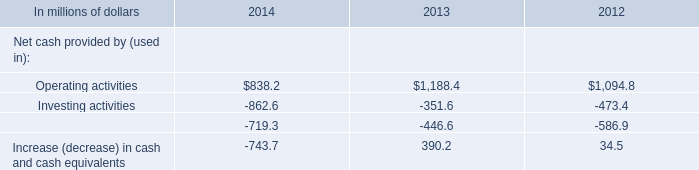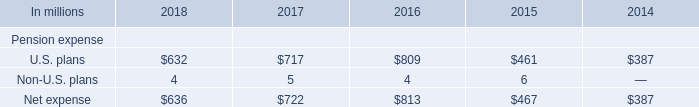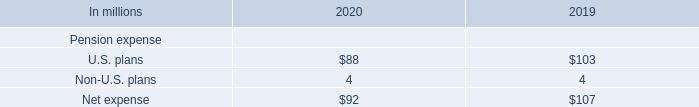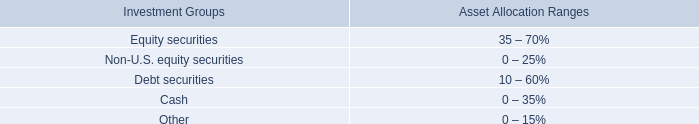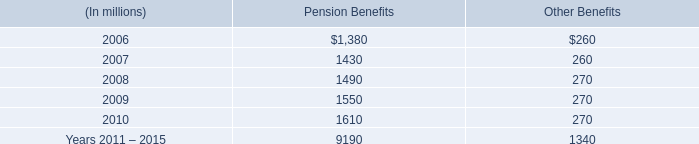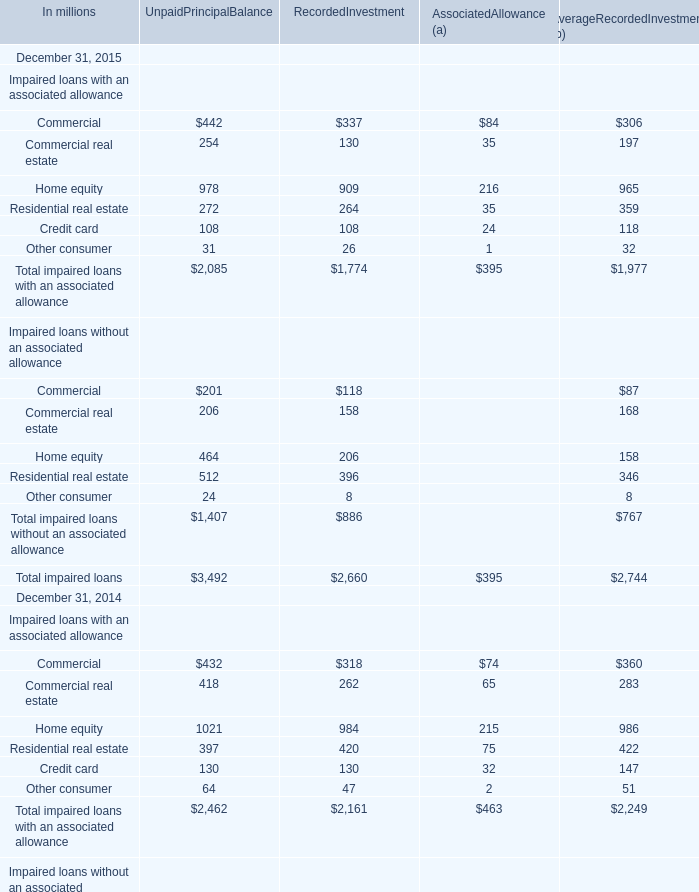What's the total value of all Commercial that are smaller than 1000 in 2015? (in million) 
Computations: (((442 + 337) + 84) + 306)
Answer: 1169.0. 